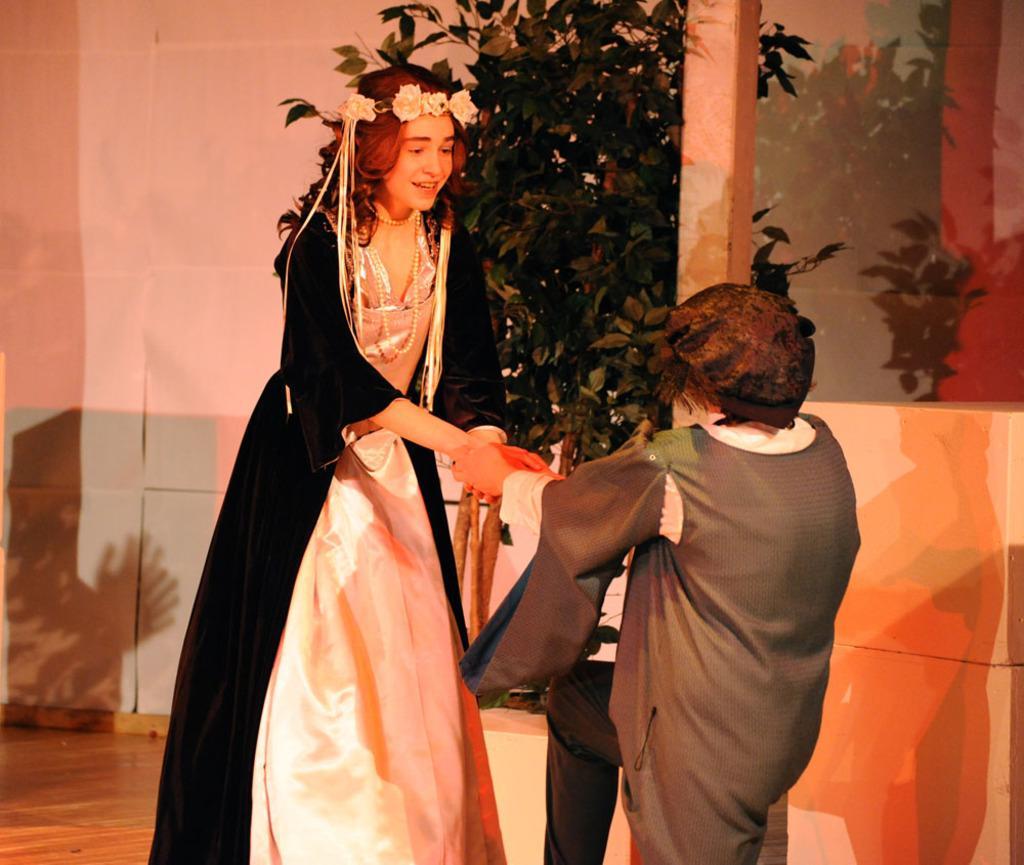Can you describe this image briefly? In this image there are two persons standing, a person holding another person hand, and in the background there is a plant, wall. 